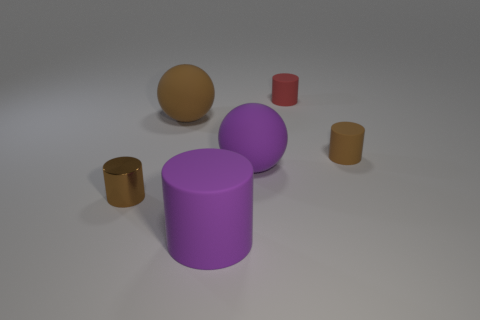Subtract 1 cylinders. How many cylinders are left? 3 Add 3 big purple objects. How many objects exist? 9 Subtract all balls. How many objects are left? 4 Add 1 large purple matte cylinders. How many large purple matte cylinders are left? 2 Add 3 big rubber objects. How many big rubber objects exist? 6 Subtract 1 brown spheres. How many objects are left? 5 Subtract all small cylinders. Subtract all brown metal cylinders. How many objects are left? 2 